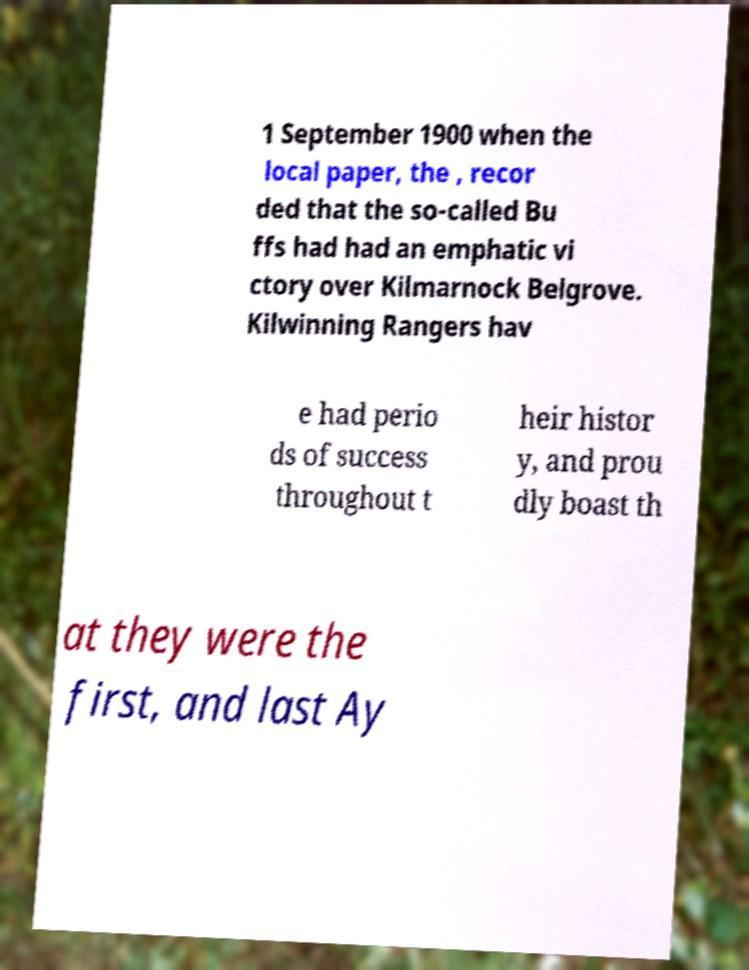I need the written content from this picture converted into text. Can you do that? 1 September 1900 when the local paper, the , recor ded that the so-called Bu ffs had had an emphatic vi ctory over Kilmarnock Belgrove. Kilwinning Rangers hav e had perio ds of success throughout t heir histor y, and prou dly boast th at they were the first, and last Ay 